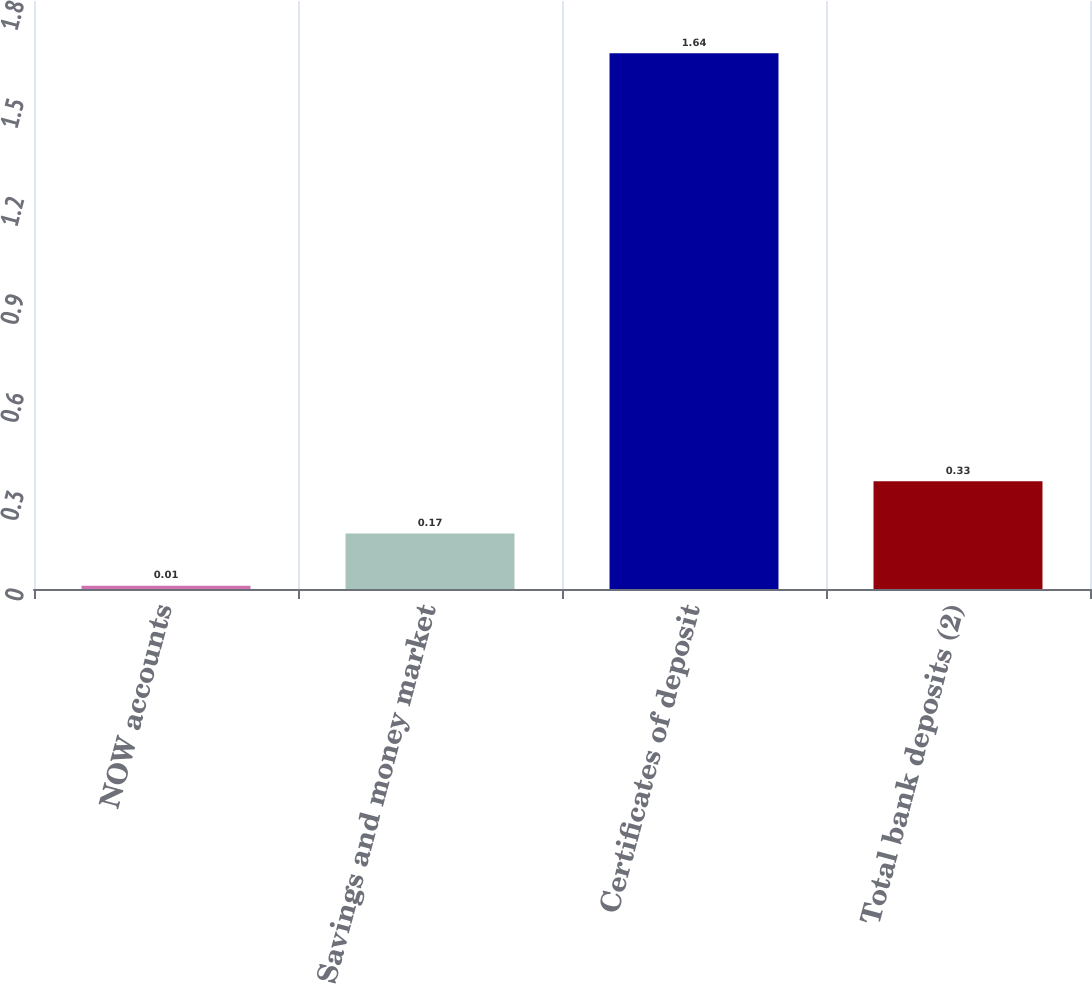Convert chart to OTSL. <chart><loc_0><loc_0><loc_500><loc_500><bar_chart><fcel>NOW accounts<fcel>Savings and money market<fcel>Certificates of deposit<fcel>Total bank deposits (2)<nl><fcel>0.01<fcel>0.17<fcel>1.64<fcel>0.33<nl></chart> 